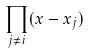Convert formula to latex. <formula><loc_0><loc_0><loc_500><loc_500>\prod _ { j \ne i } ( x - x _ { j } )</formula> 